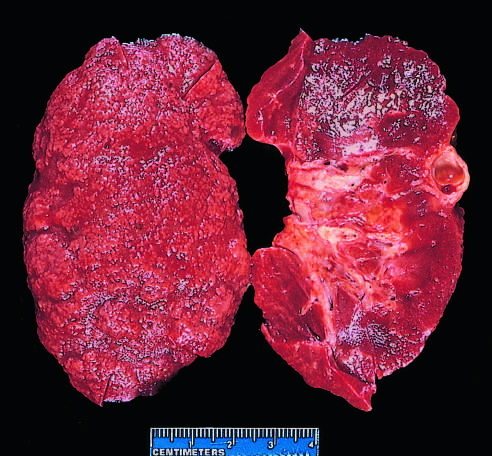does ischemic injury showing surface blebs demonstrate diffuse granular transformation of the surface and marked thinning of the cortex (right)?
Answer the question using a single word or phrase. No 